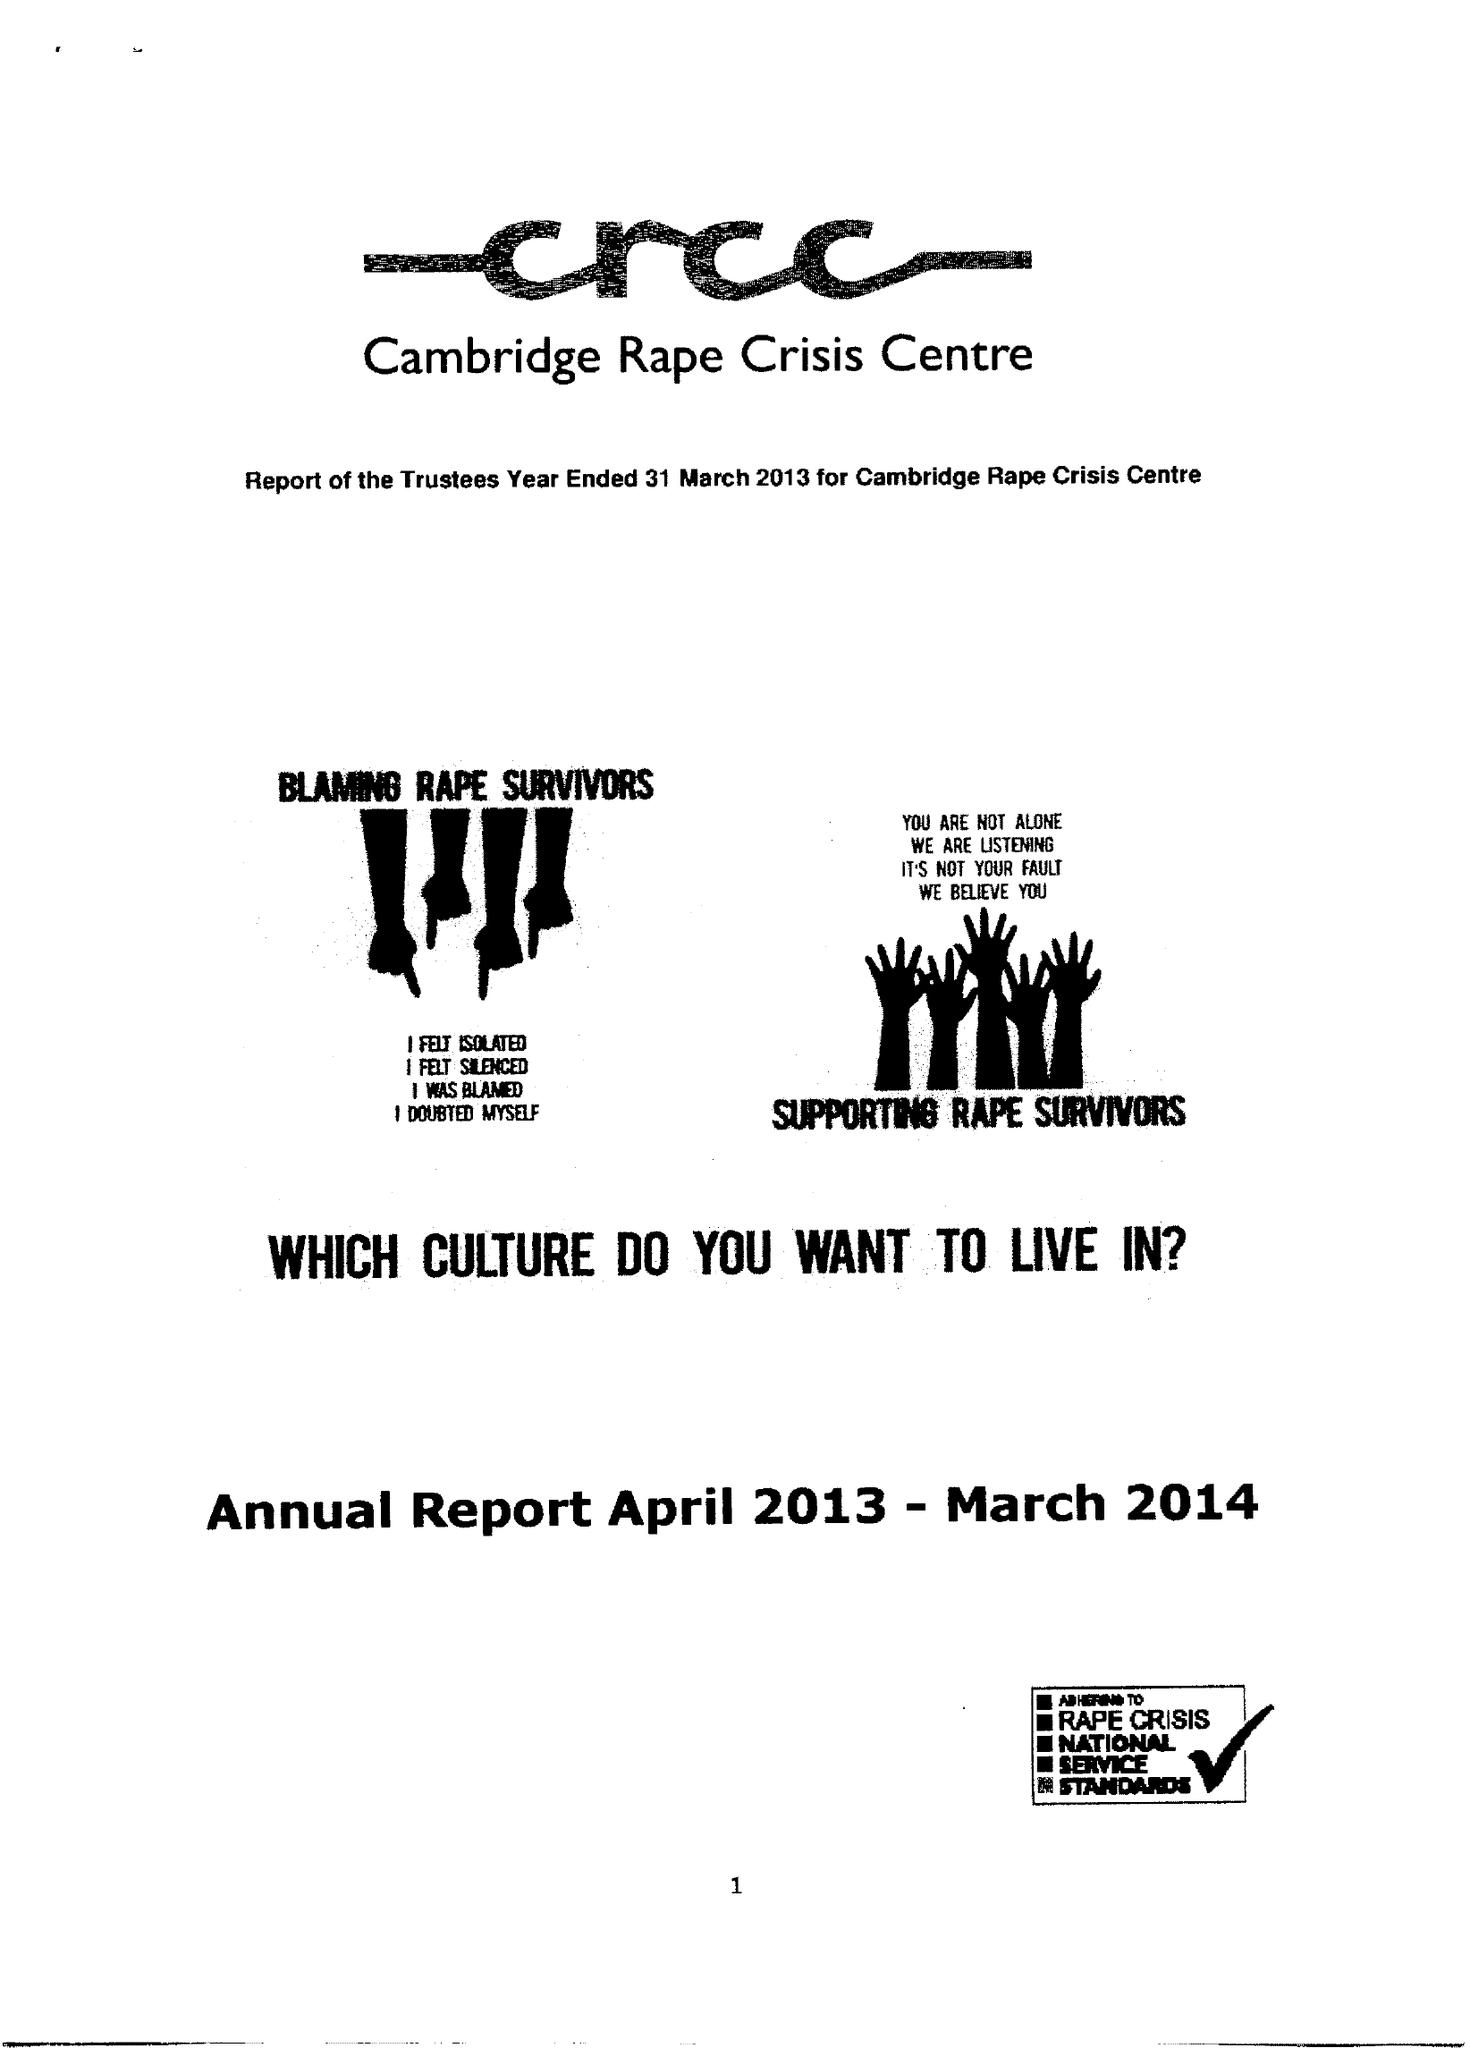What is the value for the income_annually_in_british_pounds?
Answer the question using a single word or phrase. 111201.00 